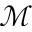Convert formula to latex. <formula><loc_0><loc_0><loc_500><loc_500>\mathcal { M }</formula> 